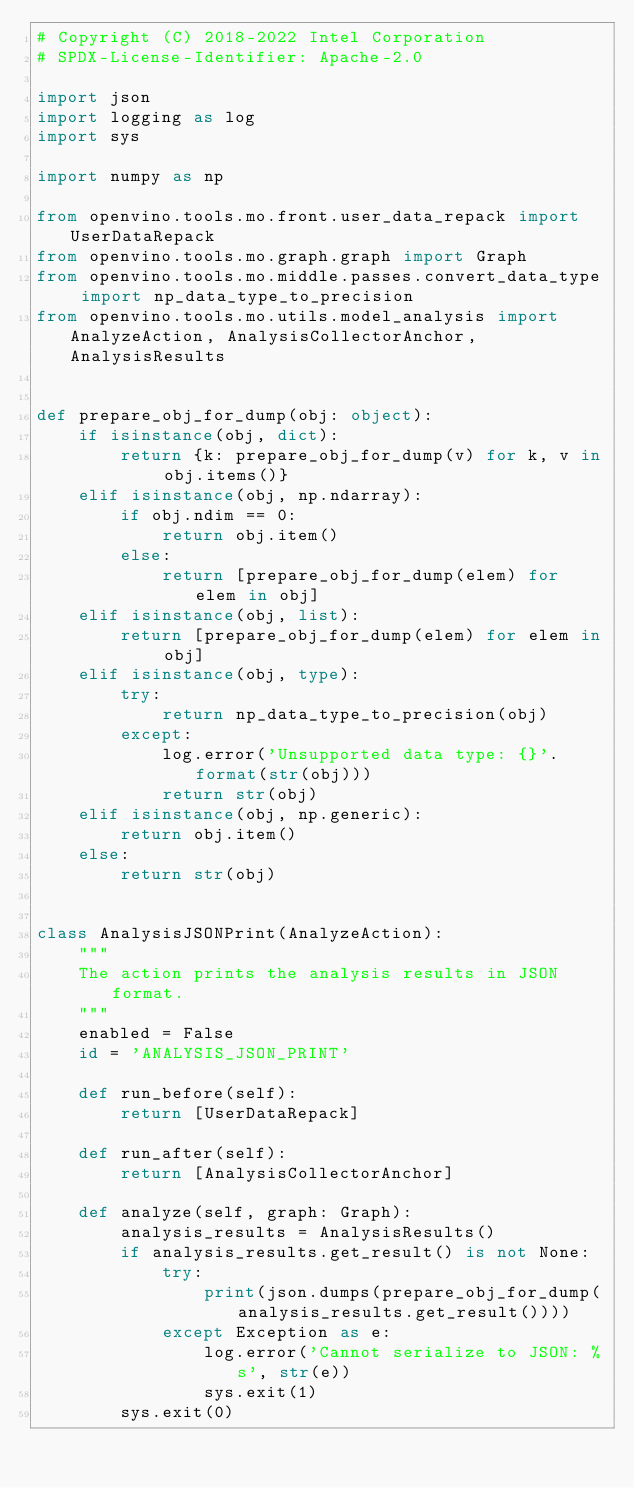<code> <loc_0><loc_0><loc_500><loc_500><_Python_># Copyright (C) 2018-2022 Intel Corporation
# SPDX-License-Identifier: Apache-2.0

import json
import logging as log
import sys

import numpy as np

from openvino.tools.mo.front.user_data_repack import UserDataRepack
from openvino.tools.mo.graph.graph import Graph
from openvino.tools.mo.middle.passes.convert_data_type import np_data_type_to_precision
from openvino.tools.mo.utils.model_analysis import AnalyzeAction, AnalysisCollectorAnchor, AnalysisResults


def prepare_obj_for_dump(obj: object):
    if isinstance(obj, dict):
        return {k: prepare_obj_for_dump(v) for k, v in obj.items()}
    elif isinstance(obj, np.ndarray):
        if obj.ndim == 0:
            return obj.item()
        else:
            return [prepare_obj_for_dump(elem) for elem in obj]
    elif isinstance(obj, list):
        return [prepare_obj_for_dump(elem) for elem in obj]
    elif isinstance(obj, type):
        try:
            return np_data_type_to_precision(obj)
        except:
            log.error('Unsupported data type: {}'.format(str(obj)))
            return str(obj)
    elif isinstance(obj, np.generic):
        return obj.item()
    else:
        return str(obj)


class AnalysisJSONPrint(AnalyzeAction):
    """
    The action prints the analysis results in JSON format.
    """
    enabled = False
    id = 'ANALYSIS_JSON_PRINT'

    def run_before(self):
        return [UserDataRepack]

    def run_after(self):
        return [AnalysisCollectorAnchor]

    def analyze(self, graph: Graph):
        analysis_results = AnalysisResults()
        if analysis_results.get_result() is not None:
            try:
                print(json.dumps(prepare_obj_for_dump(analysis_results.get_result())))
            except Exception as e:
                log.error('Cannot serialize to JSON: %s', str(e))
                sys.exit(1)
        sys.exit(0)

</code> 